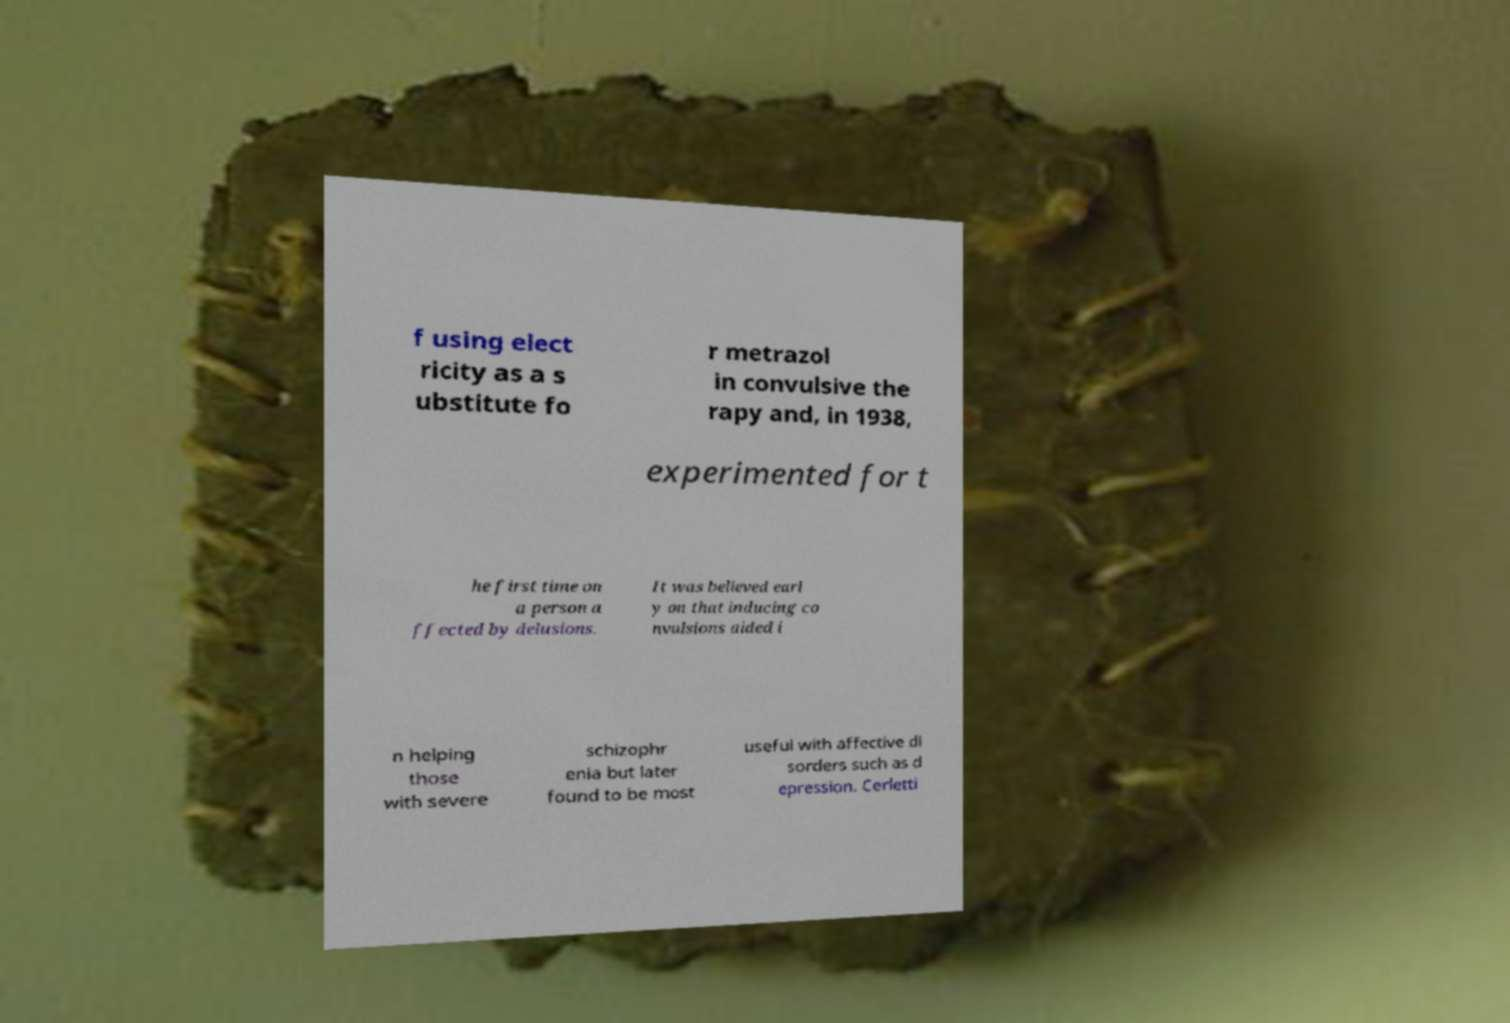For documentation purposes, I need the text within this image transcribed. Could you provide that? f using elect ricity as a s ubstitute fo r metrazol in convulsive the rapy and, in 1938, experimented for t he first time on a person a ffected by delusions. It was believed earl y on that inducing co nvulsions aided i n helping those with severe schizophr enia but later found to be most useful with affective di sorders such as d epression. Cerletti 